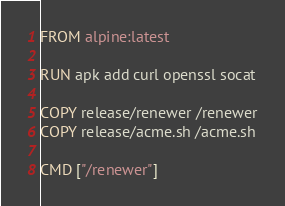<code> <loc_0><loc_0><loc_500><loc_500><_Dockerfile_>FROM alpine:latest

RUN apk add curl openssl socat

COPY release/renewer /renewer
COPY release/acme.sh /acme.sh

CMD ["/renewer"]
</code> 